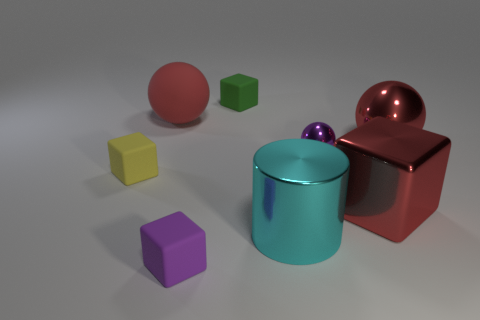How many objects are there in total, and what colors do they have? In total, there are seven objects in the image. From left to right, their colors are as follows: a red sphere, a green cube, a red cube, a purple cube, a yellow cube, a blue cylinder, and a red sphere with a reflective surface that appears a bit metallic. 